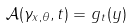<formula> <loc_0><loc_0><loc_500><loc_500>\mathcal { A } ( \gamma _ { x , \theta } , t ) = g _ { t } ( y )</formula> 